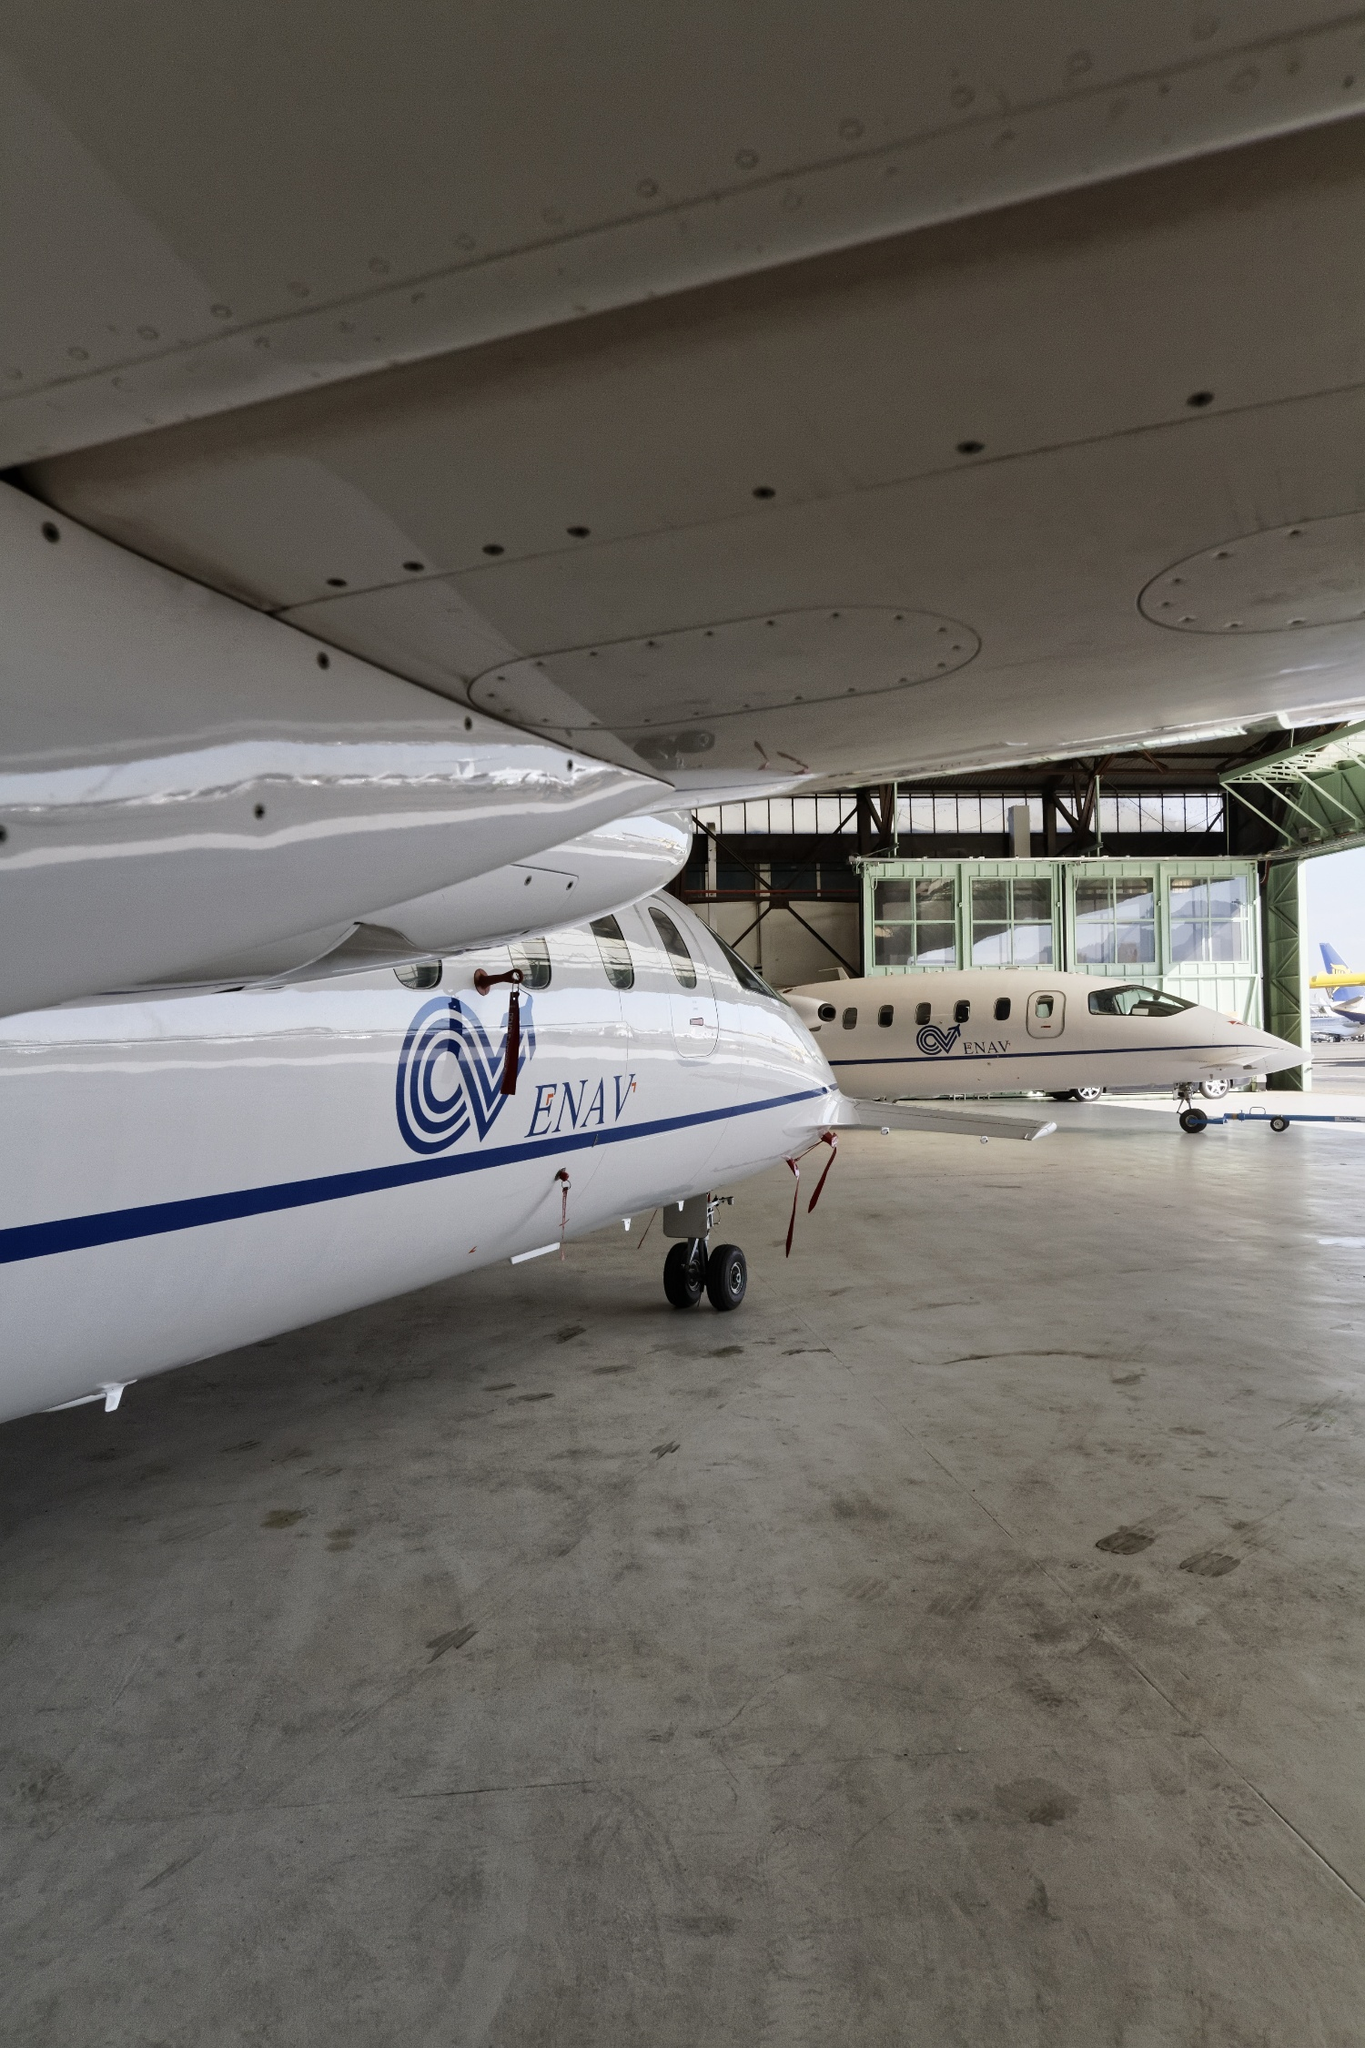How does the design and environment of the hangar contribute to the maintenance and safety of these airplanes? The hangar's design and environment play critical roles in the maintenance and safety of the airplanes it houses. The spacious design allows ample room for maneuvering and positioning the aircraft, which facilitates thorough inspections and maintenance activities. The concrete construction provides a robust and stable environment, protecting aircraft from external weather conditions. Windows positioned high in the hangar allow natural light to enter, improving visibility for technicians working on the planes. Additionally, the clean and organized layout reduces the risk of accidents or equipment damage. Describe an extraordinary event that could happen in this hangar. In a rare and extraordinary event, an astronaut might visit the hangar to conduct a pre-flight briefing for an upcoming space mission. The airplanes, temporarily repurposed, would transport key components and satellites to a nearby space launch facility. Technicians and engineers would be bustling around, ensuring that every single detail is perfect. The towering doors of the hangar would open fully to reveal a massive cargo plane arriving to transport the final, critical components. The sense of urgency and precision would permeate the air, making for a unique and momentous occasion. 